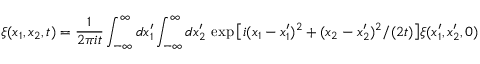<formula> <loc_0><loc_0><loc_500><loc_500>\xi ( x _ { 1 } , x _ { 2 } , t ) = \frac { 1 } { 2 \pi i t } \int _ { - \infty } ^ { \infty } d x _ { 1 } ^ { \prime } \int _ { - \infty } ^ { \infty } d x _ { 2 } ^ { \prime } \, \exp \left [ i ( x _ { 1 } - x _ { 1 } ^ { \prime } ) ^ { 2 } + ( x _ { 2 } - x _ { 2 } ^ { \prime } ) ^ { 2 } / ( 2 t ) \right ] \xi ( x _ { 1 } ^ { \prime } , x _ { 2 } ^ { \prime } , 0 )</formula> 